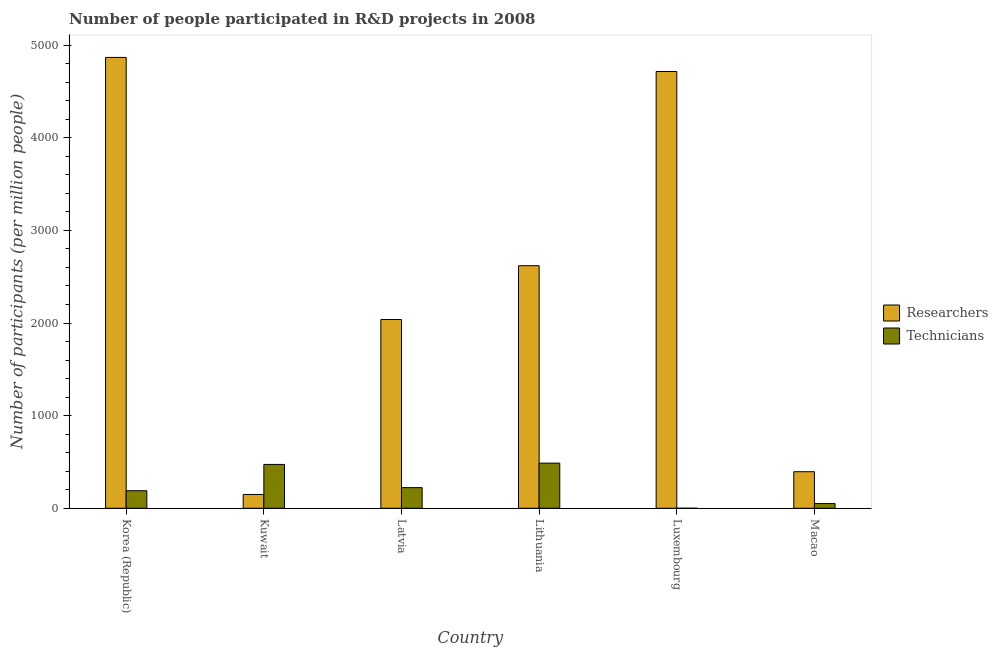How many groups of bars are there?
Give a very brief answer. 6. Are the number of bars per tick equal to the number of legend labels?
Offer a terse response. Yes. Are the number of bars on each tick of the X-axis equal?
Make the answer very short. Yes. How many bars are there on the 6th tick from the right?
Your answer should be very brief. 2. What is the label of the 2nd group of bars from the left?
Provide a succinct answer. Kuwait. What is the number of researchers in Latvia?
Keep it short and to the point. 2038.04. Across all countries, what is the maximum number of researchers?
Ensure brevity in your answer.  4867.81. Across all countries, what is the minimum number of technicians?
Make the answer very short. 0.12. In which country was the number of researchers maximum?
Provide a short and direct response. Korea (Republic). In which country was the number of researchers minimum?
Provide a succinct answer. Kuwait. What is the total number of researchers in the graph?
Offer a terse response. 1.48e+04. What is the difference between the number of researchers in Latvia and that in Macao?
Keep it short and to the point. 1643.38. What is the difference between the number of researchers in Korea (Republic) and the number of technicians in Latvia?
Your answer should be compact. 4645.07. What is the average number of technicians per country?
Your response must be concise. 237.25. What is the difference between the number of technicians and number of researchers in Luxembourg?
Provide a short and direct response. -4715.81. In how many countries, is the number of technicians greater than 3200 ?
Provide a short and direct response. 0. What is the ratio of the number of researchers in Korea (Republic) to that in Luxembourg?
Keep it short and to the point. 1.03. What is the difference between the highest and the second highest number of researchers?
Provide a succinct answer. 151.88. What is the difference between the highest and the lowest number of researchers?
Offer a terse response. 4718.85. In how many countries, is the number of researchers greater than the average number of researchers taken over all countries?
Give a very brief answer. 3. What does the 2nd bar from the left in Lithuania represents?
Offer a very short reply. Technicians. What does the 2nd bar from the right in Kuwait represents?
Make the answer very short. Researchers. How many countries are there in the graph?
Provide a short and direct response. 6. Are the values on the major ticks of Y-axis written in scientific E-notation?
Your answer should be very brief. No. Does the graph contain any zero values?
Your answer should be very brief. No. Does the graph contain grids?
Your answer should be very brief. No. Where does the legend appear in the graph?
Keep it short and to the point. Center right. How many legend labels are there?
Ensure brevity in your answer.  2. How are the legend labels stacked?
Your answer should be compact. Vertical. What is the title of the graph?
Make the answer very short. Number of people participated in R&D projects in 2008. What is the label or title of the Y-axis?
Provide a short and direct response. Number of participants (per million people). What is the Number of participants (per million people) in Researchers in Korea (Republic)?
Your answer should be very brief. 4867.81. What is the Number of participants (per million people) in Technicians in Korea (Republic)?
Offer a terse response. 189.22. What is the Number of participants (per million people) in Researchers in Kuwait?
Provide a succinct answer. 148.97. What is the Number of participants (per million people) in Technicians in Kuwait?
Ensure brevity in your answer.  473.42. What is the Number of participants (per million people) of Researchers in Latvia?
Keep it short and to the point. 2038.04. What is the Number of participants (per million people) of Technicians in Latvia?
Provide a short and direct response. 222.74. What is the Number of participants (per million people) in Researchers in Lithuania?
Your answer should be very brief. 2619.11. What is the Number of participants (per million people) in Technicians in Lithuania?
Your response must be concise. 487.31. What is the Number of participants (per million people) of Researchers in Luxembourg?
Make the answer very short. 4715.93. What is the Number of participants (per million people) of Technicians in Luxembourg?
Give a very brief answer. 0.12. What is the Number of participants (per million people) in Researchers in Macao?
Your answer should be compact. 394.66. What is the Number of participants (per million people) of Technicians in Macao?
Provide a short and direct response. 50.68. Across all countries, what is the maximum Number of participants (per million people) in Researchers?
Offer a terse response. 4867.81. Across all countries, what is the maximum Number of participants (per million people) of Technicians?
Make the answer very short. 487.31. Across all countries, what is the minimum Number of participants (per million people) of Researchers?
Offer a very short reply. 148.97. Across all countries, what is the minimum Number of participants (per million people) of Technicians?
Your answer should be very brief. 0.12. What is the total Number of participants (per million people) in Researchers in the graph?
Your answer should be compact. 1.48e+04. What is the total Number of participants (per million people) of Technicians in the graph?
Your answer should be compact. 1423.49. What is the difference between the Number of participants (per million people) in Researchers in Korea (Republic) and that in Kuwait?
Ensure brevity in your answer.  4718.85. What is the difference between the Number of participants (per million people) in Technicians in Korea (Republic) and that in Kuwait?
Your response must be concise. -284.2. What is the difference between the Number of participants (per million people) in Researchers in Korea (Republic) and that in Latvia?
Your answer should be compact. 2829.77. What is the difference between the Number of participants (per million people) in Technicians in Korea (Republic) and that in Latvia?
Your answer should be very brief. -33.52. What is the difference between the Number of participants (per million people) of Researchers in Korea (Republic) and that in Lithuania?
Keep it short and to the point. 2248.71. What is the difference between the Number of participants (per million people) in Technicians in Korea (Republic) and that in Lithuania?
Your response must be concise. -298.09. What is the difference between the Number of participants (per million people) in Researchers in Korea (Republic) and that in Luxembourg?
Ensure brevity in your answer.  151.88. What is the difference between the Number of participants (per million people) in Technicians in Korea (Republic) and that in Luxembourg?
Your answer should be very brief. 189.1. What is the difference between the Number of participants (per million people) in Researchers in Korea (Republic) and that in Macao?
Provide a short and direct response. 4473.16. What is the difference between the Number of participants (per million people) in Technicians in Korea (Republic) and that in Macao?
Offer a terse response. 138.54. What is the difference between the Number of participants (per million people) of Researchers in Kuwait and that in Latvia?
Give a very brief answer. -1889.07. What is the difference between the Number of participants (per million people) of Technicians in Kuwait and that in Latvia?
Give a very brief answer. 250.68. What is the difference between the Number of participants (per million people) of Researchers in Kuwait and that in Lithuania?
Your response must be concise. -2470.14. What is the difference between the Number of participants (per million people) of Technicians in Kuwait and that in Lithuania?
Provide a succinct answer. -13.89. What is the difference between the Number of participants (per million people) of Researchers in Kuwait and that in Luxembourg?
Keep it short and to the point. -4566.97. What is the difference between the Number of participants (per million people) in Technicians in Kuwait and that in Luxembourg?
Your answer should be compact. 473.3. What is the difference between the Number of participants (per million people) of Researchers in Kuwait and that in Macao?
Make the answer very short. -245.69. What is the difference between the Number of participants (per million people) in Technicians in Kuwait and that in Macao?
Make the answer very short. 422.74. What is the difference between the Number of participants (per million people) of Researchers in Latvia and that in Lithuania?
Make the answer very short. -581.06. What is the difference between the Number of participants (per million people) of Technicians in Latvia and that in Lithuania?
Your answer should be very brief. -264.57. What is the difference between the Number of participants (per million people) in Researchers in Latvia and that in Luxembourg?
Provide a short and direct response. -2677.89. What is the difference between the Number of participants (per million people) in Technicians in Latvia and that in Luxembourg?
Give a very brief answer. 222.62. What is the difference between the Number of participants (per million people) in Researchers in Latvia and that in Macao?
Your answer should be compact. 1643.38. What is the difference between the Number of participants (per million people) of Technicians in Latvia and that in Macao?
Offer a very short reply. 172.06. What is the difference between the Number of participants (per million people) of Researchers in Lithuania and that in Luxembourg?
Your response must be concise. -2096.83. What is the difference between the Number of participants (per million people) of Technicians in Lithuania and that in Luxembourg?
Provide a succinct answer. 487.18. What is the difference between the Number of participants (per million people) in Researchers in Lithuania and that in Macao?
Provide a succinct answer. 2224.45. What is the difference between the Number of participants (per million people) in Technicians in Lithuania and that in Macao?
Your response must be concise. 436.63. What is the difference between the Number of participants (per million people) in Researchers in Luxembourg and that in Macao?
Offer a very short reply. 4321.27. What is the difference between the Number of participants (per million people) of Technicians in Luxembourg and that in Macao?
Provide a succinct answer. -50.56. What is the difference between the Number of participants (per million people) in Researchers in Korea (Republic) and the Number of participants (per million people) in Technicians in Kuwait?
Ensure brevity in your answer.  4394.4. What is the difference between the Number of participants (per million people) of Researchers in Korea (Republic) and the Number of participants (per million people) of Technicians in Latvia?
Your response must be concise. 4645.07. What is the difference between the Number of participants (per million people) of Researchers in Korea (Republic) and the Number of participants (per million people) of Technicians in Lithuania?
Make the answer very short. 4380.51. What is the difference between the Number of participants (per million people) in Researchers in Korea (Republic) and the Number of participants (per million people) in Technicians in Luxembourg?
Your answer should be compact. 4867.69. What is the difference between the Number of participants (per million people) in Researchers in Korea (Republic) and the Number of participants (per million people) in Technicians in Macao?
Give a very brief answer. 4817.13. What is the difference between the Number of participants (per million people) in Researchers in Kuwait and the Number of participants (per million people) in Technicians in Latvia?
Ensure brevity in your answer.  -73.77. What is the difference between the Number of participants (per million people) of Researchers in Kuwait and the Number of participants (per million people) of Technicians in Lithuania?
Make the answer very short. -338.34. What is the difference between the Number of participants (per million people) in Researchers in Kuwait and the Number of participants (per million people) in Technicians in Luxembourg?
Your response must be concise. 148.84. What is the difference between the Number of participants (per million people) of Researchers in Kuwait and the Number of participants (per million people) of Technicians in Macao?
Your response must be concise. 98.29. What is the difference between the Number of participants (per million people) in Researchers in Latvia and the Number of participants (per million people) in Technicians in Lithuania?
Provide a succinct answer. 1550.73. What is the difference between the Number of participants (per million people) in Researchers in Latvia and the Number of participants (per million people) in Technicians in Luxembourg?
Provide a succinct answer. 2037.92. What is the difference between the Number of participants (per million people) of Researchers in Latvia and the Number of participants (per million people) of Technicians in Macao?
Your response must be concise. 1987.36. What is the difference between the Number of participants (per million people) of Researchers in Lithuania and the Number of participants (per million people) of Technicians in Luxembourg?
Offer a very short reply. 2618.98. What is the difference between the Number of participants (per million people) of Researchers in Lithuania and the Number of participants (per million people) of Technicians in Macao?
Your response must be concise. 2568.43. What is the difference between the Number of participants (per million people) in Researchers in Luxembourg and the Number of participants (per million people) in Technicians in Macao?
Your answer should be very brief. 4665.25. What is the average Number of participants (per million people) of Researchers per country?
Keep it short and to the point. 2464.09. What is the average Number of participants (per million people) in Technicians per country?
Offer a terse response. 237.25. What is the difference between the Number of participants (per million people) in Researchers and Number of participants (per million people) in Technicians in Korea (Republic)?
Your answer should be very brief. 4678.59. What is the difference between the Number of participants (per million people) of Researchers and Number of participants (per million people) of Technicians in Kuwait?
Provide a succinct answer. -324.45. What is the difference between the Number of participants (per million people) of Researchers and Number of participants (per million people) of Technicians in Latvia?
Give a very brief answer. 1815.3. What is the difference between the Number of participants (per million people) in Researchers and Number of participants (per million people) in Technicians in Lithuania?
Provide a succinct answer. 2131.8. What is the difference between the Number of participants (per million people) of Researchers and Number of participants (per million people) of Technicians in Luxembourg?
Offer a terse response. 4715.81. What is the difference between the Number of participants (per million people) of Researchers and Number of participants (per million people) of Technicians in Macao?
Make the answer very short. 343.98. What is the ratio of the Number of participants (per million people) in Researchers in Korea (Republic) to that in Kuwait?
Your answer should be compact. 32.68. What is the ratio of the Number of participants (per million people) of Technicians in Korea (Republic) to that in Kuwait?
Make the answer very short. 0.4. What is the ratio of the Number of participants (per million people) in Researchers in Korea (Republic) to that in Latvia?
Your answer should be compact. 2.39. What is the ratio of the Number of participants (per million people) in Technicians in Korea (Republic) to that in Latvia?
Make the answer very short. 0.85. What is the ratio of the Number of participants (per million people) of Researchers in Korea (Republic) to that in Lithuania?
Make the answer very short. 1.86. What is the ratio of the Number of participants (per million people) of Technicians in Korea (Republic) to that in Lithuania?
Offer a terse response. 0.39. What is the ratio of the Number of participants (per million people) in Researchers in Korea (Republic) to that in Luxembourg?
Your response must be concise. 1.03. What is the ratio of the Number of participants (per million people) of Technicians in Korea (Republic) to that in Luxembourg?
Give a very brief answer. 1537.51. What is the ratio of the Number of participants (per million people) of Researchers in Korea (Republic) to that in Macao?
Your answer should be very brief. 12.33. What is the ratio of the Number of participants (per million people) of Technicians in Korea (Republic) to that in Macao?
Give a very brief answer. 3.73. What is the ratio of the Number of participants (per million people) in Researchers in Kuwait to that in Latvia?
Provide a succinct answer. 0.07. What is the ratio of the Number of participants (per million people) of Technicians in Kuwait to that in Latvia?
Your answer should be compact. 2.13. What is the ratio of the Number of participants (per million people) in Researchers in Kuwait to that in Lithuania?
Make the answer very short. 0.06. What is the ratio of the Number of participants (per million people) in Technicians in Kuwait to that in Lithuania?
Give a very brief answer. 0.97. What is the ratio of the Number of participants (per million people) of Researchers in Kuwait to that in Luxembourg?
Your response must be concise. 0.03. What is the ratio of the Number of participants (per million people) in Technicians in Kuwait to that in Luxembourg?
Give a very brief answer. 3846.74. What is the ratio of the Number of participants (per million people) in Researchers in Kuwait to that in Macao?
Provide a short and direct response. 0.38. What is the ratio of the Number of participants (per million people) of Technicians in Kuwait to that in Macao?
Ensure brevity in your answer.  9.34. What is the ratio of the Number of participants (per million people) in Researchers in Latvia to that in Lithuania?
Provide a short and direct response. 0.78. What is the ratio of the Number of participants (per million people) of Technicians in Latvia to that in Lithuania?
Give a very brief answer. 0.46. What is the ratio of the Number of participants (per million people) in Researchers in Latvia to that in Luxembourg?
Provide a short and direct response. 0.43. What is the ratio of the Number of participants (per million people) of Technicians in Latvia to that in Luxembourg?
Make the answer very short. 1809.86. What is the ratio of the Number of participants (per million people) in Researchers in Latvia to that in Macao?
Give a very brief answer. 5.16. What is the ratio of the Number of participants (per million people) of Technicians in Latvia to that in Macao?
Your answer should be very brief. 4.39. What is the ratio of the Number of participants (per million people) in Researchers in Lithuania to that in Luxembourg?
Ensure brevity in your answer.  0.56. What is the ratio of the Number of participants (per million people) of Technicians in Lithuania to that in Luxembourg?
Your response must be concise. 3959.6. What is the ratio of the Number of participants (per million people) of Researchers in Lithuania to that in Macao?
Offer a terse response. 6.64. What is the ratio of the Number of participants (per million people) of Technicians in Lithuania to that in Macao?
Offer a very short reply. 9.62. What is the ratio of the Number of participants (per million people) of Researchers in Luxembourg to that in Macao?
Make the answer very short. 11.95. What is the ratio of the Number of participants (per million people) in Technicians in Luxembourg to that in Macao?
Your answer should be very brief. 0. What is the difference between the highest and the second highest Number of participants (per million people) of Researchers?
Offer a terse response. 151.88. What is the difference between the highest and the second highest Number of participants (per million people) in Technicians?
Offer a very short reply. 13.89. What is the difference between the highest and the lowest Number of participants (per million people) of Researchers?
Your answer should be compact. 4718.85. What is the difference between the highest and the lowest Number of participants (per million people) in Technicians?
Offer a very short reply. 487.18. 